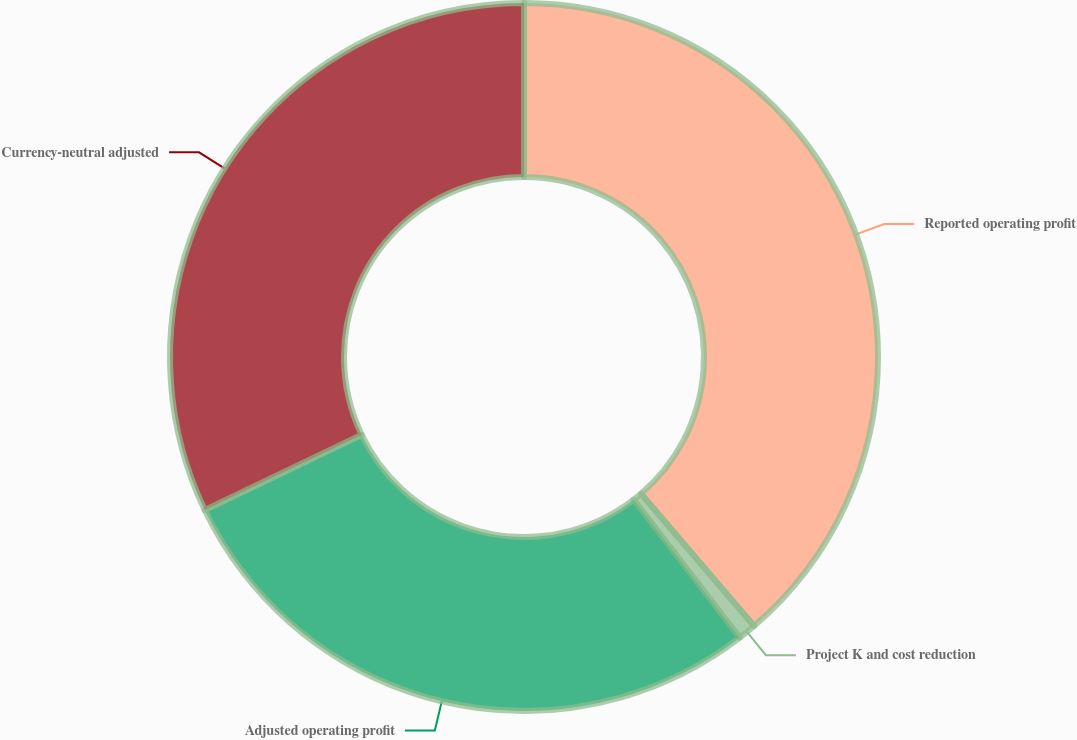Convert chart. <chart><loc_0><loc_0><loc_500><loc_500><pie_chart><fcel>Reported operating profit<fcel>Project K and cost reduction<fcel>Adjusted operating profit<fcel>Currency-neutral adjusted<nl><fcel>38.74%<fcel>0.83%<fcel>28.32%<fcel>32.11%<nl></chart> 